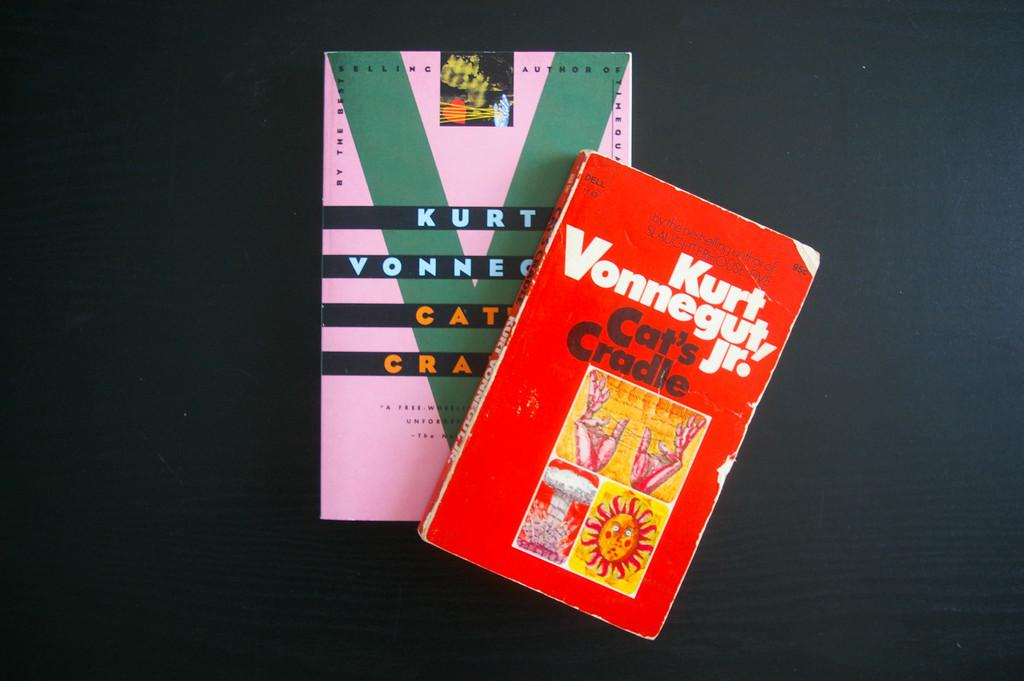<image>
Give a short and clear explanation of the subsequent image. a book on top of another book by kurt vonnegut jr. 